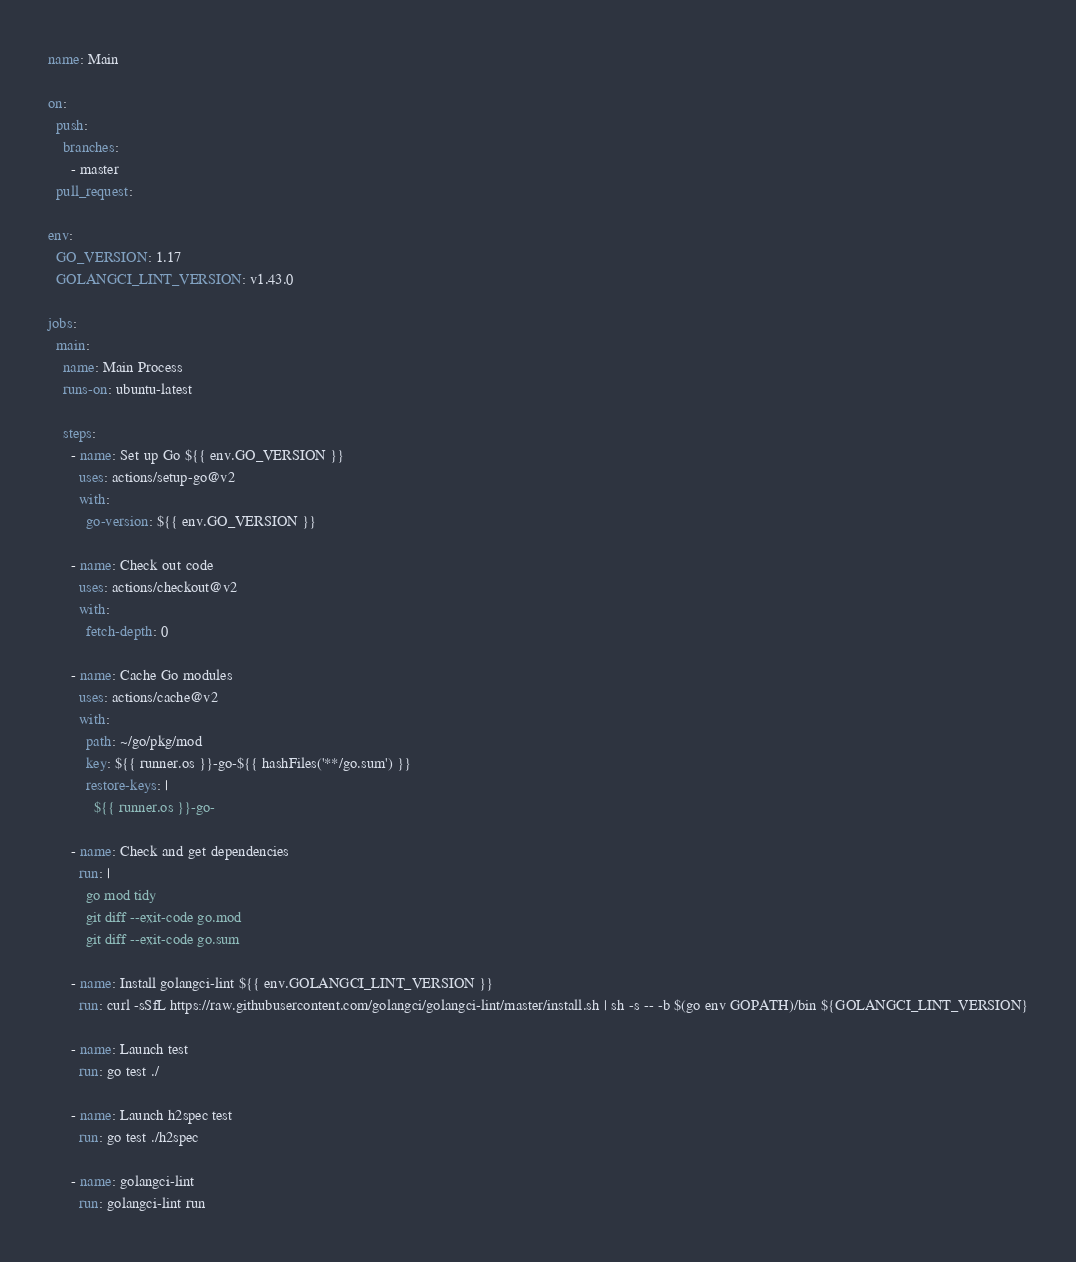<code> <loc_0><loc_0><loc_500><loc_500><_YAML_>name: Main

on:
  push:
    branches:
      - master
  pull_request:

env:
  GO_VERSION: 1.17
  GOLANGCI_LINT_VERSION: v1.43.0

jobs:
  main:
    name: Main Process
    runs-on: ubuntu-latest

    steps:
      - name: Set up Go ${{ env.GO_VERSION }}
        uses: actions/setup-go@v2
        with:
          go-version: ${{ env.GO_VERSION }}

      - name: Check out code
        uses: actions/checkout@v2
        with:
          fetch-depth: 0

      - name: Cache Go modules
        uses: actions/cache@v2
        with:
          path: ~/go/pkg/mod
          key: ${{ runner.os }}-go-${{ hashFiles('**/go.sum') }}
          restore-keys: |
            ${{ runner.os }}-go-

      - name: Check and get dependencies
        run: |
          go mod tidy
          git diff --exit-code go.mod
          git diff --exit-code go.sum

      - name: Install golangci-lint ${{ env.GOLANGCI_LINT_VERSION }}
        run: curl -sSfL https://raw.githubusercontent.com/golangci/golangci-lint/master/install.sh | sh -s -- -b $(go env GOPATH)/bin ${GOLANGCI_LINT_VERSION}

      - name: Launch test
        run: go test ./

      - name: Launch h2spec test
        run: go test ./h2spec

      - name: golangci-lint
        run: golangci-lint run
</code> 